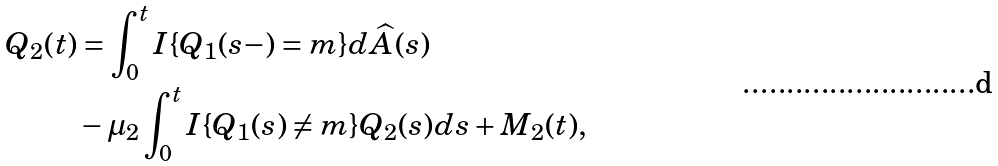Convert formula to latex. <formula><loc_0><loc_0><loc_500><loc_500>Q _ { 2 } ( t ) & = \int _ { 0 } ^ { t } { I } \{ Q _ { 1 } ( s - ) = m \} d \widehat { A } ( s ) \\ & - \mu _ { 2 } \int _ { 0 } ^ { t } { I } \{ Q _ { 1 } ( s ) \neq m \} Q _ { 2 } ( s ) d s + M _ { 2 } ( t ) ,</formula> 